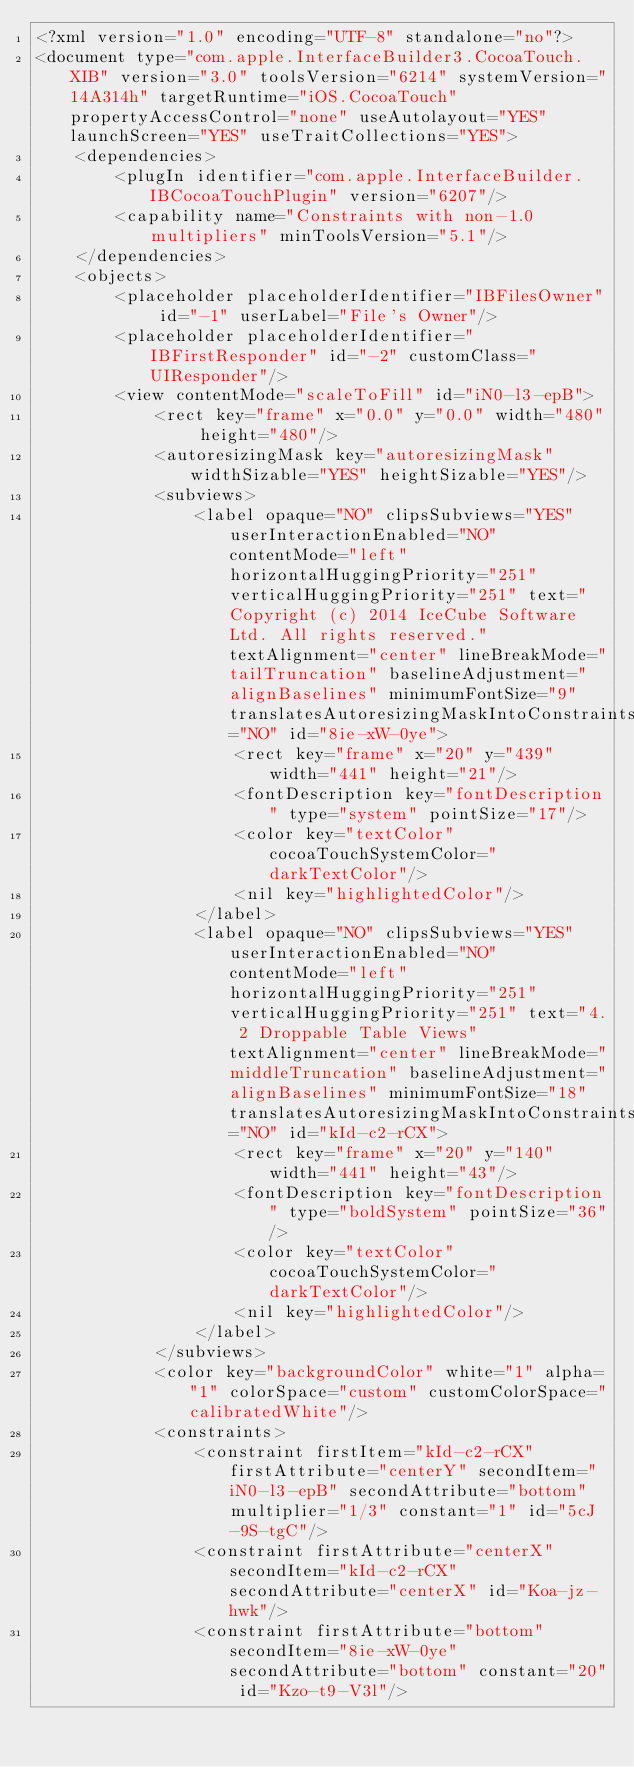<code> <loc_0><loc_0><loc_500><loc_500><_XML_><?xml version="1.0" encoding="UTF-8" standalone="no"?>
<document type="com.apple.InterfaceBuilder3.CocoaTouch.XIB" version="3.0" toolsVersion="6214" systemVersion="14A314h" targetRuntime="iOS.CocoaTouch" propertyAccessControl="none" useAutolayout="YES" launchScreen="YES" useTraitCollections="YES">
    <dependencies>
        <plugIn identifier="com.apple.InterfaceBuilder.IBCocoaTouchPlugin" version="6207"/>
        <capability name="Constraints with non-1.0 multipliers" minToolsVersion="5.1"/>
    </dependencies>
    <objects>
        <placeholder placeholderIdentifier="IBFilesOwner" id="-1" userLabel="File's Owner"/>
        <placeholder placeholderIdentifier="IBFirstResponder" id="-2" customClass="UIResponder"/>
        <view contentMode="scaleToFill" id="iN0-l3-epB">
            <rect key="frame" x="0.0" y="0.0" width="480" height="480"/>
            <autoresizingMask key="autoresizingMask" widthSizable="YES" heightSizable="YES"/>
            <subviews>
                <label opaque="NO" clipsSubviews="YES" userInteractionEnabled="NO" contentMode="left" horizontalHuggingPriority="251" verticalHuggingPriority="251" text="  Copyright (c) 2014 IceCube Software Ltd. All rights reserved." textAlignment="center" lineBreakMode="tailTruncation" baselineAdjustment="alignBaselines" minimumFontSize="9" translatesAutoresizingMaskIntoConstraints="NO" id="8ie-xW-0ye">
                    <rect key="frame" x="20" y="439" width="441" height="21"/>
                    <fontDescription key="fontDescription" type="system" pointSize="17"/>
                    <color key="textColor" cocoaTouchSystemColor="darkTextColor"/>
                    <nil key="highlightedColor"/>
                </label>
                <label opaque="NO" clipsSubviews="YES" userInteractionEnabled="NO" contentMode="left" horizontalHuggingPriority="251" verticalHuggingPriority="251" text="4. 2 Droppable Table Views" textAlignment="center" lineBreakMode="middleTruncation" baselineAdjustment="alignBaselines" minimumFontSize="18" translatesAutoresizingMaskIntoConstraints="NO" id="kId-c2-rCX">
                    <rect key="frame" x="20" y="140" width="441" height="43"/>
                    <fontDescription key="fontDescription" type="boldSystem" pointSize="36"/>
                    <color key="textColor" cocoaTouchSystemColor="darkTextColor"/>
                    <nil key="highlightedColor"/>
                </label>
            </subviews>
            <color key="backgroundColor" white="1" alpha="1" colorSpace="custom" customColorSpace="calibratedWhite"/>
            <constraints>
                <constraint firstItem="kId-c2-rCX" firstAttribute="centerY" secondItem="iN0-l3-epB" secondAttribute="bottom" multiplier="1/3" constant="1" id="5cJ-9S-tgC"/>
                <constraint firstAttribute="centerX" secondItem="kId-c2-rCX" secondAttribute="centerX" id="Koa-jz-hwk"/>
                <constraint firstAttribute="bottom" secondItem="8ie-xW-0ye" secondAttribute="bottom" constant="20" id="Kzo-t9-V3l"/></code> 